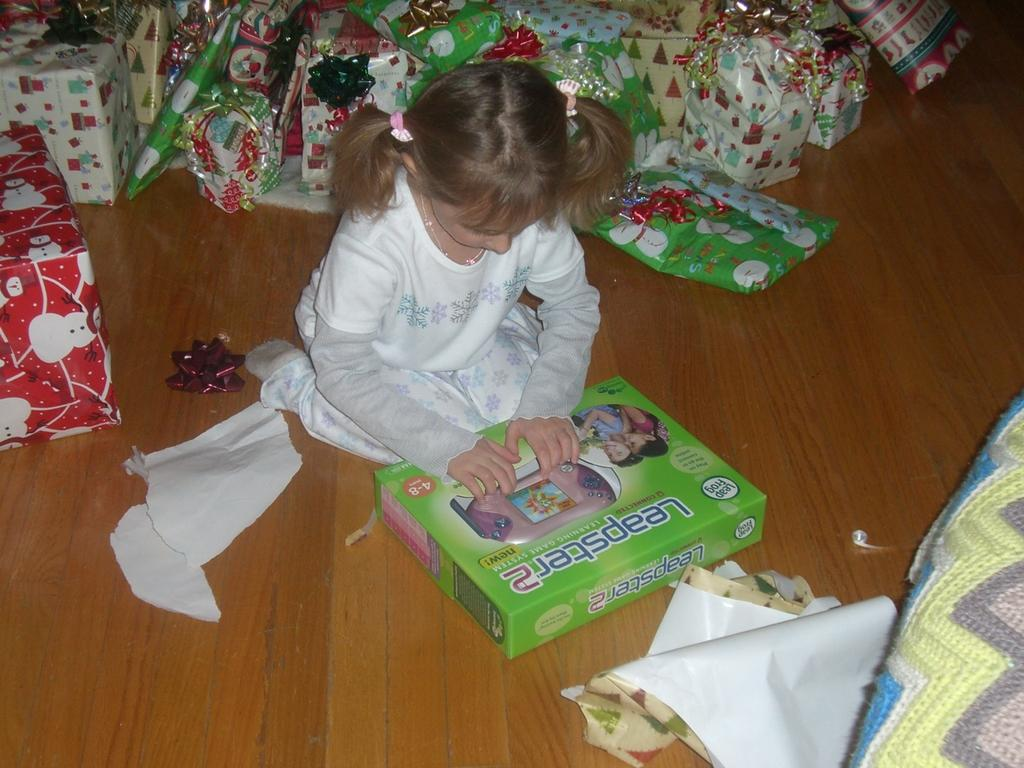What is the girl in the image doing? The girl is seated on the floor in the image. What is the girl holding in the image? The girl is holding a box in the image. Where is the box located in the image? The box is on the floor in the image. What else can be seen on the floor in the image? There are gifts, boxes, and papers visible on the floor in the image. Is the girl in jail in the image? No, there is no indication that the girl is in jail in the image. 